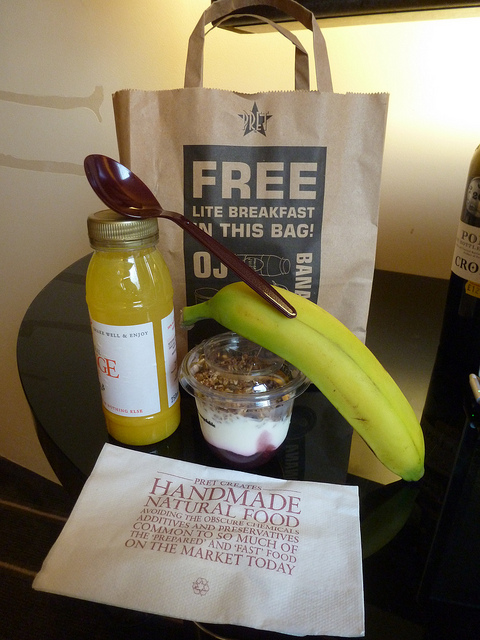Identify and read out the text in this image. FREE LITE BREAKFAST THIS BAG TODY MARKET THE ON FOOD FAST AND PREPARED THE OF MUCH TO COMMON AND ADDITIVES SO PRESERVATIVES CHEMICALS OBSCURE THE AVOIDING FOOD NATURAL HANDMADE CRRATES PRFI PO GE ENJOY BANA OJ PRE 